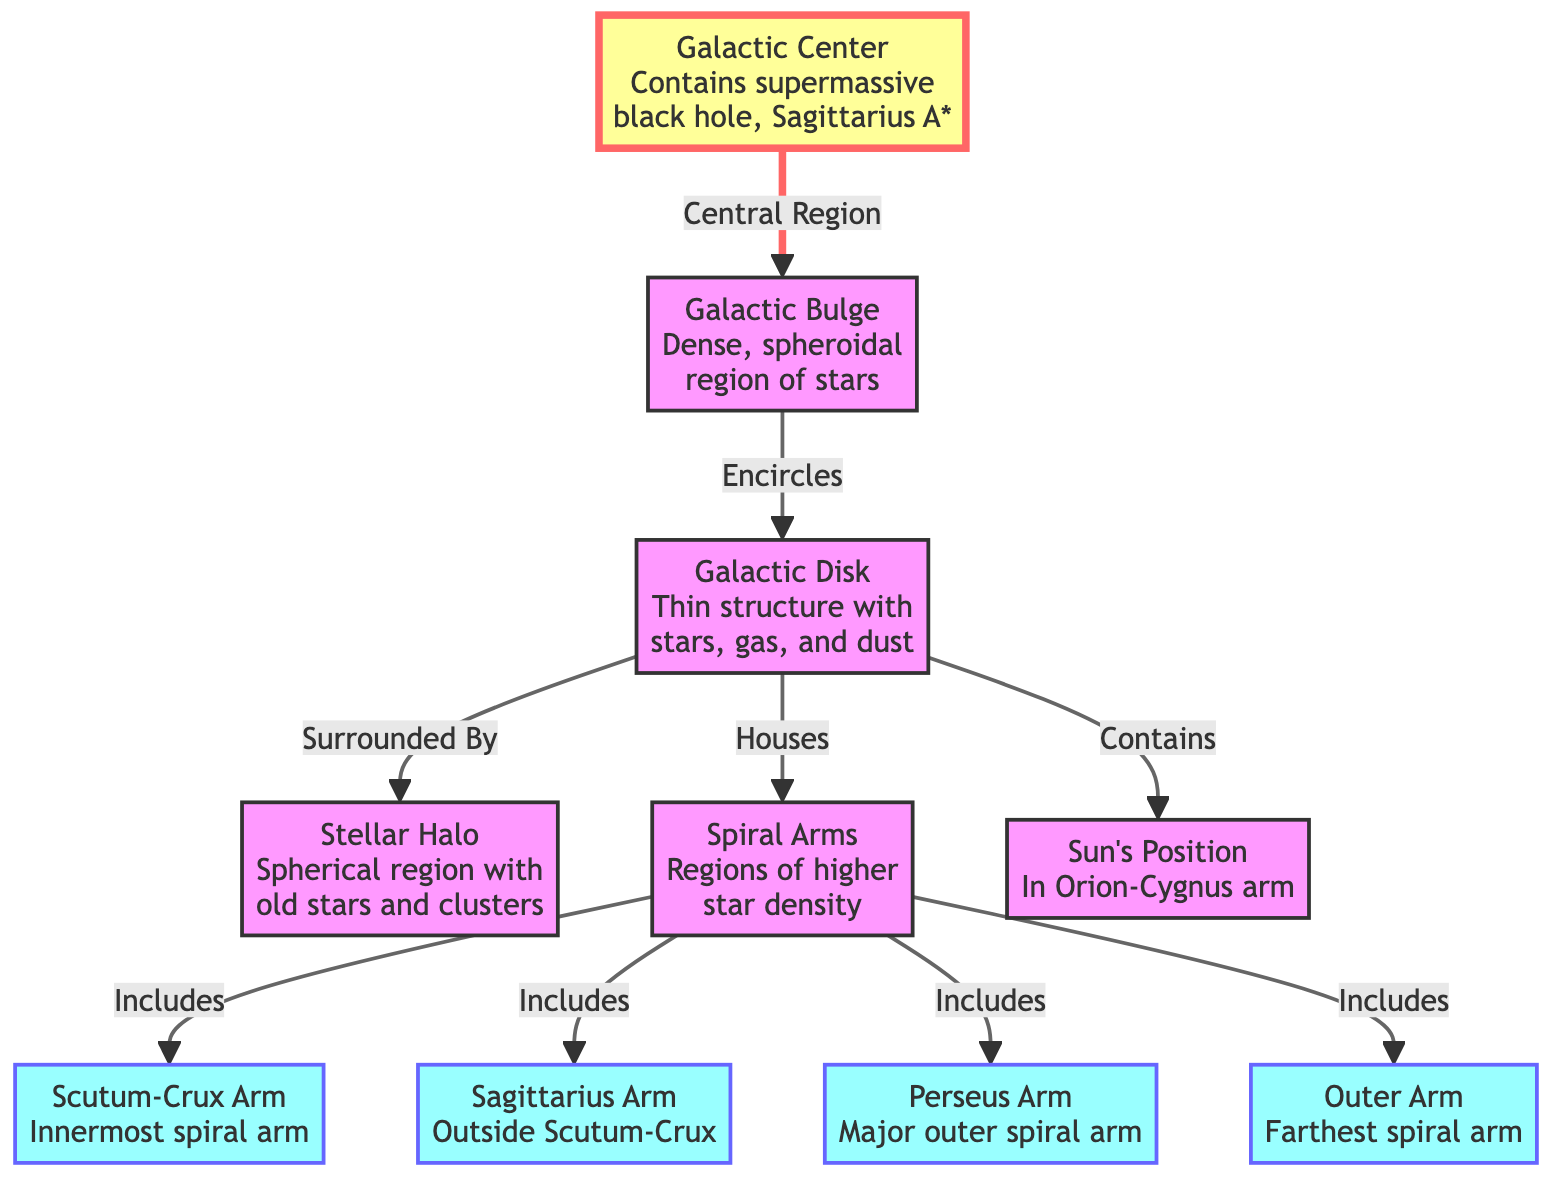What is at the Galactic Center? The diagram indicates that the Galactic Center contains a supermassive black hole known as Sagittarius A*. This is shown directly in the center node of the diagram.
Answer: supermassive black hole, Sagittarius A* How many spiral arms are listed? The diagram explicitly lists four spiral arms: Scutum-Crux Arm, Sagittarius Arm, Perseus Arm, and Outer Arm. Counting these gives a total of four arms.
Answer: 4 What does the Galactic Bulge encircle? According to the diagram, the Galactic Bulge encircles the Galactic Disk. This is indicated by the directional connection from the bulge node to the disk node.
Answer: Galactic Disk Where is the Sun's position located? The diagram clearly states that the Sun's position is in the Orion-Cygnus arm. This information can be found in the node labeled "Sun's Position."
Answer: Orion-Cygnus arm Which is the innermost spiral arm? The diagram shows that the Scutum-Crux Arm is specified as the innermost spiral arm in the corresponding node description.
Answer: Scutum-Crux Arm What surrounds the Galactic Disk? The diagram identifies that the Stellar Halo surrounds the Galactic Disk, as shown by the connection pointing outward from the disk node.
Answer: Stellar Halo How many major components of the Milky Way are mentioned? The diagram highlights five major components: Galactic Center, Galactic Bulge, Galactic Disk, Stellar Halo, and Spiral Arms. Counting these gives five components.
Answer: 5 Which arm is the major outer spiral arm? The diagram designates the Perseus Arm as the major outer spiral arm. This specific information can be found in the description of that arm node.
Answer: Perseus Arm What is included in the Galactic Disk? The diagram indicates that the Galactic Disk houses the Spiral Arms and contains the Sun's position. Thus, both arms and the Sun's position are included in the disk.
Answer: Spiral Arms, Sun's Position 